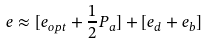<formula> <loc_0><loc_0><loc_500><loc_500>e \approx [ e _ { o p t } + \frac { 1 } { 2 } P _ { a } ] + [ e _ { d } + e _ { b } ]</formula> 